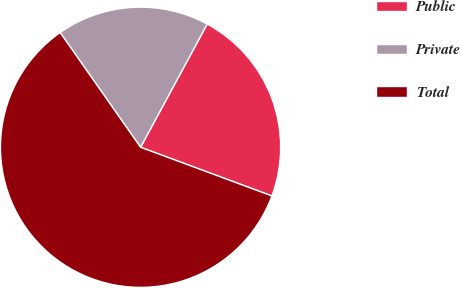Convert chart to OTSL. <chart><loc_0><loc_0><loc_500><loc_500><pie_chart><fcel>Public<fcel>Private<fcel>Total<nl><fcel>22.76%<fcel>17.62%<fcel>59.62%<nl></chart> 